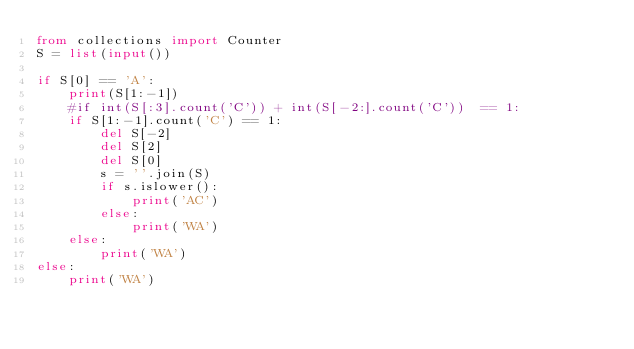<code> <loc_0><loc_0><loc_500><loc_500><_Python_>from collections import Counter
S = list(input())

if S[0] == 'A':
    print(S[1:-1])
    #if int(S[:3].count('C')) + int(S[-2:].count('C'))  == 1:
    if S[1:-1].count('C') == 1:
        del S[-2]
        del S[2]
        del S[0]
        s = ''.join(S)
        if s.islower():
            print('AC')
        else:
            print('WA')
    else:
        print('WA')
else:
    print('WA')
</code> 